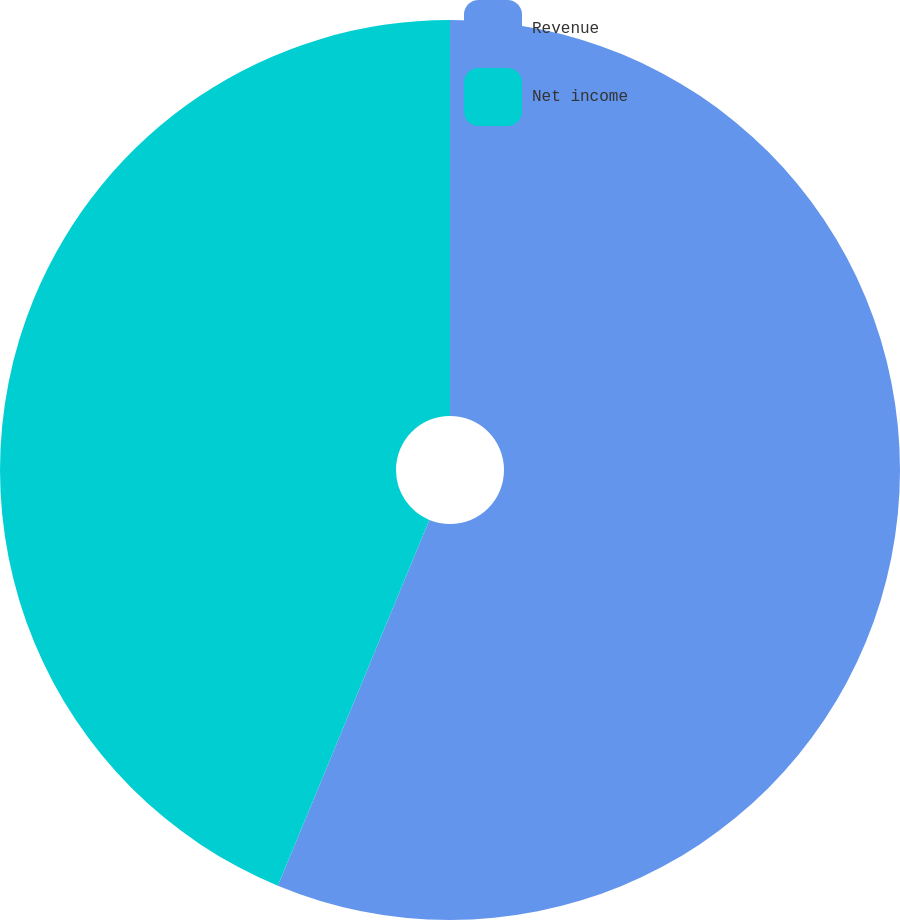<chart> <loc_0><loc_0><loc_500><loc_500><pie_chart><fcel>Revenue<fcel>Net income<nl><fcel>56.25%<fcel>43.75%<nl></chart> 